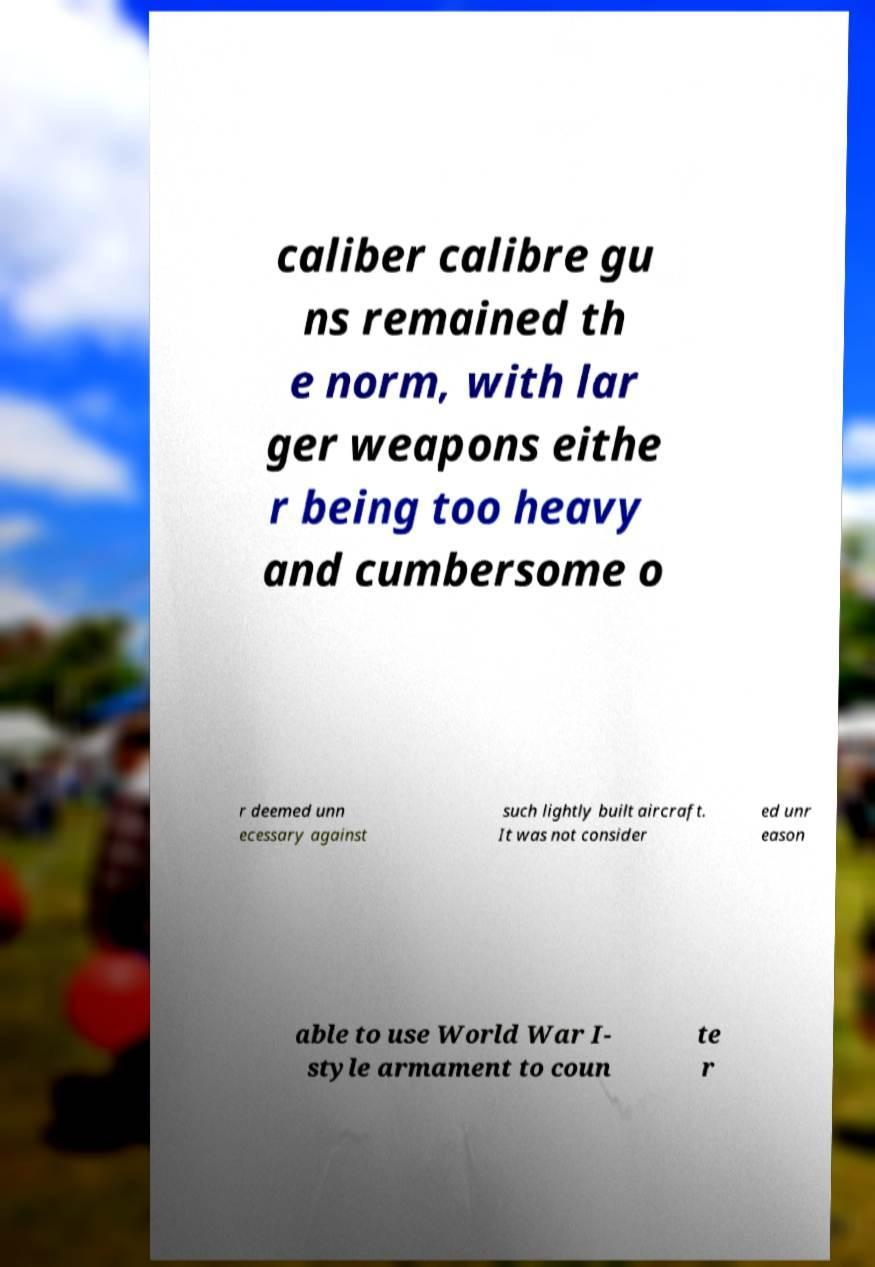I need the written content from this picture converted into text. Can you do that? caliber calibre gu ns remained th e norm, with lar ger weapons eithe r being too heavy and cumbersome o r deemed unn ecessary against such lightly built aircraft. It was not consider ed unr eason able to use World War I- style armament to coun te r 